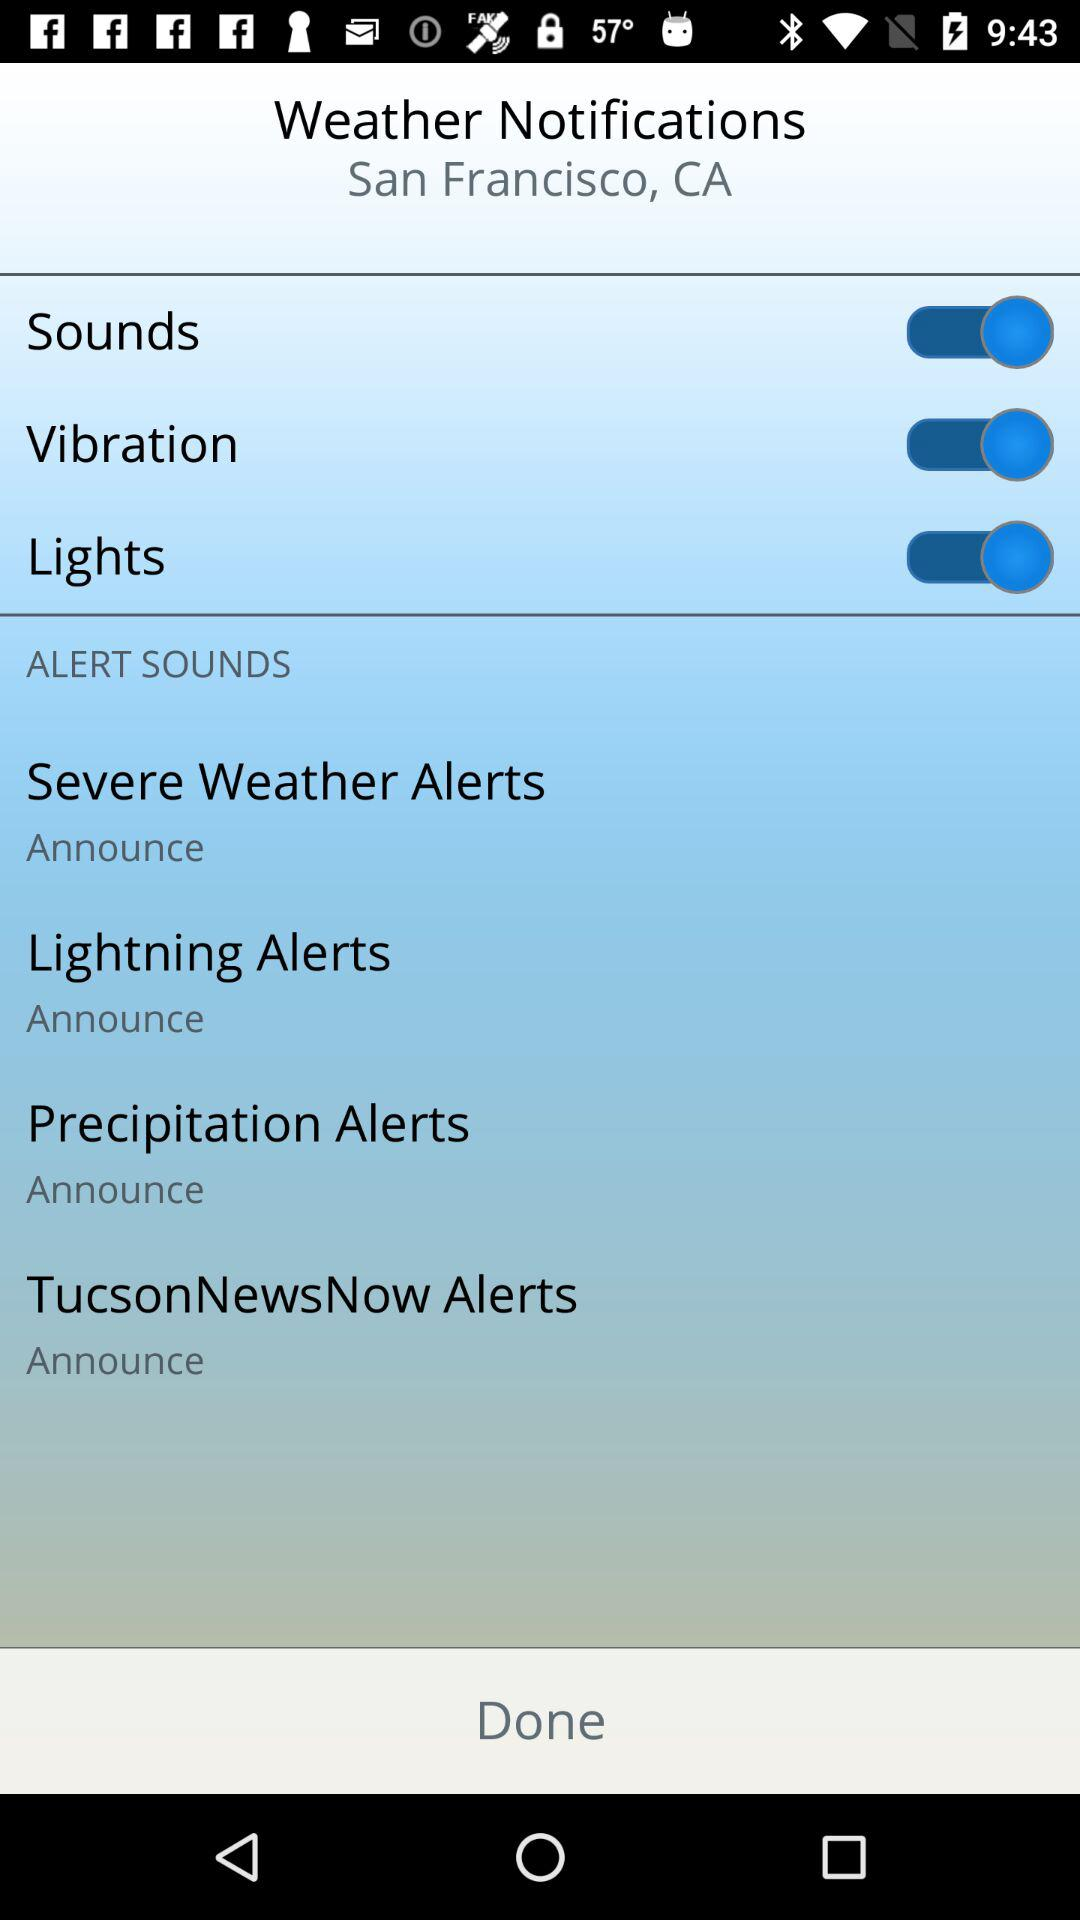How many alert sounds are available?
Answer the question using a single word or phrase. 4 